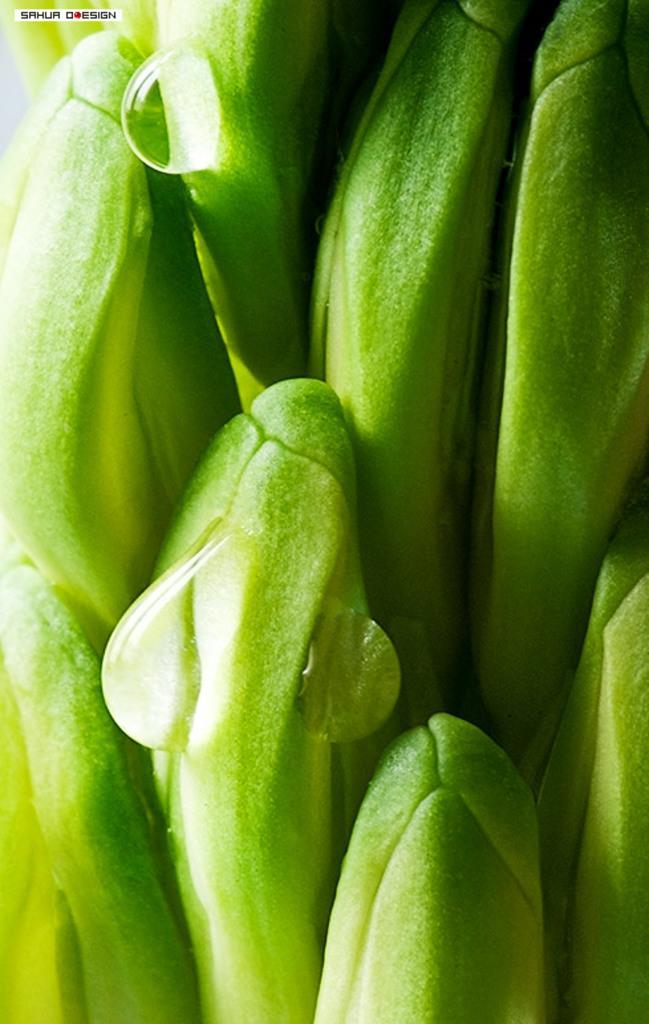Please provide a concise description of this image. In this image we can see some water drops on a plant. In the top left corner of the image we can see some text. 